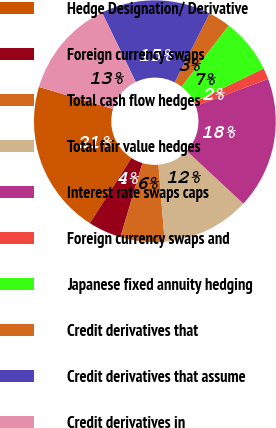Convert chart. <chart><loc_0><loc_0><loc_500><loc_500><pie_chart><fcel>Hedge Designation/ Derivative<fcel>Foreign currency swaps<fcel>Total cash flow hedges<fcel>Total fair value hedges<fcel>Interest rate swaps caps<fcel>Foreign currency swaps and<fcel>Japanese fixed annuity hedging<fcel>Credit derivatives that<fcel>Credit derivatives that assume<fcel>Credit derivatives in<nl><fcel>20.55%<fcel>4.43%<fcel>5.9%<fcel>11.76%<fcel>17.62%<fcel>1.5%<fcel>7.36%<fcel>2.97%<fcel>14.69%<fcel>13.22%<nl></chart> 